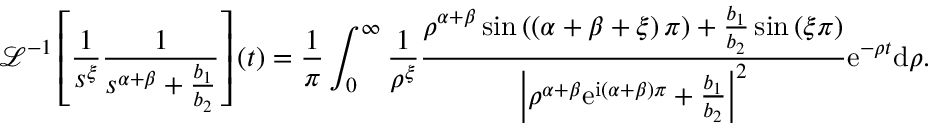<formula> <loc_0><loc_0><loc_500><loc_500>\mathcal { L } ^ { - 1 } \left [ \frac { 1 } { s ^ { \xi } } \frac { 1 } { s ^ { \alpha + \beta } + \frac { b _ { 1 } } { b _ { 2 } } } \right ] \left ( t \right ) = \frac { 1 } { \pi } \int _ { 0 } ^ { \infty } \frac { 1 } { \rho ^ { \xi } } \frac { \rho ^ { \alpha + \beta } \sin \left ( \left ( \alpha + \beta + \xi \right ) \pi \right ) + \frac { b _ { 1 } } { b _ { 2 } } \sin \left ( \xi \pi \right ) } { \left | \rho ^ { \alpha + \beta } e ^ { i \left ( \alpha + \beta \right ) \pi } + \frac { b _ { 1 } } { b _ { 2 } } \right | ^ { 2 } } e ^ { - \rho t } d \rho .</formula> 